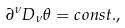<formula> <loc_0><loc_0><loc_500><loc_500>\partial ^ { \nu } D _ { \nu } \theta = c o n s t . ,</formula> 